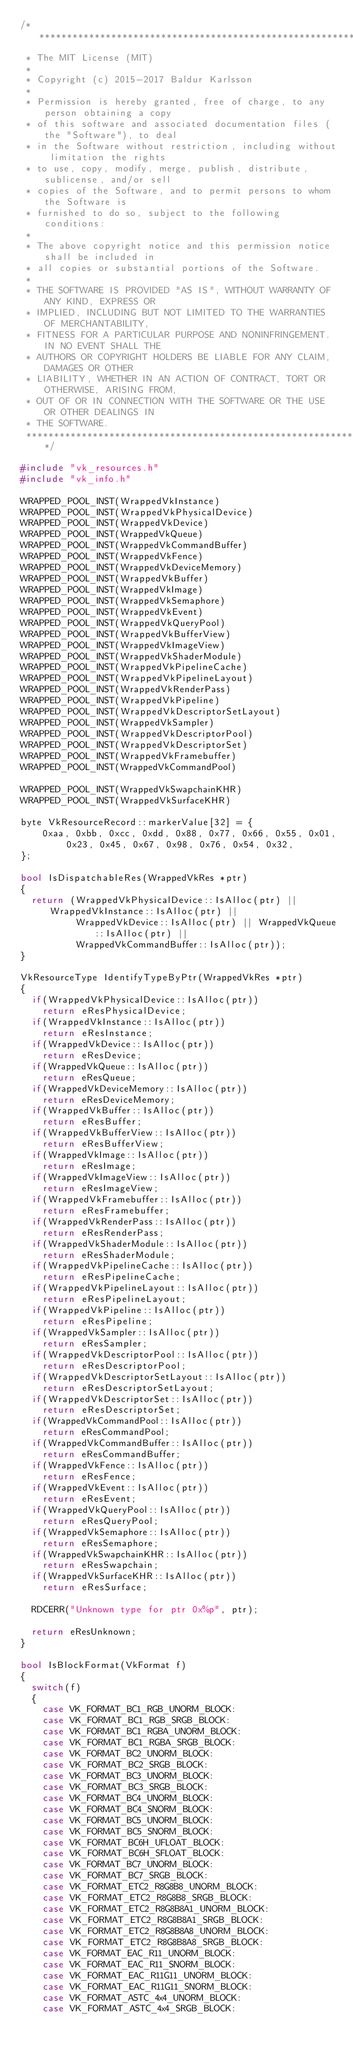Convert code to text. <code><loc_0><loc_0><loc_500><loc_500><_C++_>/******************************************************************************
 * The MIT License (MIT)
 *
 * Copyright (c) 2015-2017 Baldur Karlsson
 *
 * Permission is hereby granted, free of charge, to any person obtaining a copy
 * of this software and associated documentation files (the "Software"), to deal
 * in the Software without restriction, including without limitation the rights
 * to use, copy, modify, merge, publish, distribute, sublicense, and/or sell
 * copies of the Software, and to permit persons to whom the Software is
 * furnished to do so, subject to the following conditions:
 *
 * The above copyright notice and this permission notice shall be included in
 * all copies or substantial portions of the Software.
 *
 * THE SOFTWARE IS PROVIDED "AS IS", WITHOUT WARRANTY OF ANY KIND, EXPRESS OR
 * IMPLIED, INCLUDING BUT NOT LIMITED TO THE WARRANTIES OF MERCHANTABILITY,
 * FITNESS FOR A PARTICULAR PURPOSE AND NONINFRINGEMENT. IN NO EVENT SHALL THE
 * AUTHORS OR COPYRIGHT HOLDERS BE LIABLE FOR ANY CLAIM, DAMAGES OR OTHER
 * LIABILITY, WHETHER IN AN ACTION OF CONTRACT, TORT OR OTHERWISE, ARISING FROM,
 * OUT OF OR IN CONNECTION WITH THE SOFTWARE OR THE USE OR OTHER DEALINGS IN
 * THE SOFTWARE.
 ******************************************************************************/

#include "vk_resources.h"
#include "vk_info.h"

WRAPPED_POOL_INST(WrappedVkInstance)
WRAPPED_POOL_INST(WrappedVkPhysicalDevice)
WRAPPED_POOL_INST(WrappedVkDevice)
WRAPPED_POOL_INST(WrappedVkQueue)
WRAPPED_POOL_INST(WrappedVkCommandBuffer)
WRAPPED_POOL_INST(WrappedVkFence)
WRAPPED_POOL_INST(WrappedVkDeviceMemory)
WRAPPED_POOL_INST(WrappedVkBuffer)
WRAPPED_POOL_INST(WrappedVkImage)
WRAPPED_POOL_INST(WrappedVkSemaphore)
WRAPPED_POOL_INST(WrappedVkEvent)
WRAPPED_POOL_INST(WrappedVkQueryPool)
WRAPPED_POOL_INST(WrappedVkBufferView)
WRAPPED_POOL_INST(WrappedVkImageView)
WRAPPED_POOL_INST(WrappedVkShaderModule)
WRAPPED_POOL_INST(WrappedVkPipelineCache)
WRAPPED_POOL_INST(WrappedVkPipelineLayout)
WRAPPED_POOL_INST(WrappedVkRenderPass)
WRAPPED_POOL_INST(WrappedVkPipeline)
WRAPPED_POOL_INST(WrappedVkDescriptorSetLayout)
WRAPPED_POOL_INST(WrappedVkSampler)
WRAPPED_POOL_INST(WrappedVkDescriptorPool)
WRAPPED_POOL_INST(WrappedVkDescriptorSet)
WRAPPED_POOL_INST(WrappedVkFramebuffer)
WRAPPED_POOL_INST(WrappedVkCommandPool)

WRAPPED_POOL_INST(WrappedVkSwapchainKHR)
WRAPPED_POOL_INST(WrappedVkSurfaceKHR)

byte VkResourceRecord::markerValue[32] = {
    0xaa, 0xbb, 0xcc, 0xdd, 0x88, 0x77, 0x66, 0x55, 0x01, 0x23, 0x45, 0x67, 0x98, 0x76, 0x54, 0x32,
};

bool IsDispatchableRes(WrappedVkRes *ptr)
{
  return (WrappedVkPhysicalDevice::IsAlloc(ptr) || WrappedVkInstance::IsAlloc(ptr) ||
          WrappedVkDevice::IsAlloc(ptr) || WrappedVkQueue::IsAlloc(ptr) ||
          WrappedVkCommandBuffer::IsAlloc(ptr));
}

VkResourceType IdentifyTypeByPtr(WrappedVkRes *ptr)
{
  if(WrappedVkPhysicalDevice::IsAlloc(ptr))
    return eResPhysicalDevice;
  if(WrappedVkInstance::IsAlloc(ptr))
    return eResInstance;
  if(WrappedVkDevice::IsAlloc(ptr))
    return eResDevice;
  if(WrappedVkQueue::IsAlloc(ptr))
    return eResQueue;
  if(WrappedVkDeviceMemory::IsAlloc(ptr))
    return eResDeviceMemory;
  if(WrappedVkBuffer::IsAlloc(ptr))
    return eResBuffer;
  if(WrappedVkBufferView::IsAlloc(ptr))
    return eResBufferView;
  if(WrappedVkImage::IsAlloc(ptr))
    return eResImage;
  if(WrappedVkImageView::IsAlloc(ptr))
    return eResImageView;
  if(WrappedVkFramebuffer::IsAlloc(ptr))
    return eResFramebuffer;
  if(WrappedVkRenderPass::IsAlloc(ptr))
    return eResRenderPass;
  if(WrappedVkShaderModule::IsAlloc(ptr))
    return eResShaderModule;
  if(WrappedVkPipelineCache::IsAlloc(ptr))
    return eResPipelineCache;
  if(WrappedVkPipelineLayout::IsAlloc(ptr))
    return eResPipelineLayout;
  if(WrappedVkPipeline::IsAlloc(ptr))
    return eResPipeline;
  if(WrappedVkSampler::IsAlloc(ptr))
    return eResSampler;
  if(WrappedVkDescriptorPool::IsAlloc(ptr))
    return eResDescriptorPool;
  if(WrappedVkDescriptorSetLayout::IsAlloc(ptr))
    return eResDescriptorSetLayout;
  if(WrappedVkDescriptorSet::IsAlloc(ptr))
    return eResDescriptorSet;
  if(WrappedVkCommandPool::IsAlloc(ptr))
    return eResCommandPool;
  if(WrappedVkCommandBuffer::IsAlloc(ptr))
    return eResCommandBuffer;
  if(WrappedVkFence::IsAlloc(ptr))
    return eResFence;
  if(WrappedVkEvent::IsAlloc(ptr))
    return eResEvent;
  if(WrappedVkQueryPool::IsAlloc(ptr))
    return eResQueryPool;
  if(WrappedVkSemaphore::IsAlloc(ptr))
    return eResSemaphore;
  if(WrappedVkSwapchainKHR::IsAlloc(ptr))
    return eResSwapchain;
  if(WrappedVkSurfaceKHR::IsAlloc(ptr))
    return eResSurface;

  RDCERR("Unknown type for ptr 0x%p", ptr);

  return eResUnknown;
}

bool IsBlockFormat(VkFormat f)
{
  switch(f)
  {
    case VK_FORMAT_BC1_RGB_UNORM_BLOCK:
    case VK_FORMAT_BC1_RGB_SRGB_BLOCK:
    case VK_FORMAT_BC1_RGBA_UNORM_BLOCK:
    case VK_FORMAT_BC1_RGBA_SRGB_BLOCK:
    case VK_FORMAT_BC2_UNORM_BLOCK:
    case VK_FORMAT_BC2_SRGB_BLOCK:
    case VK_FORMAT_BC3_UNORM_BLOCK:
    case VK_FORMAT_BC3_SRGB_BLOCK:
    case VK_FORMAT_BC4_UNORM_BLOCK:
    case VK_FORMAT_BC4_SNORM_BLOCK:
    case VK_FORMAT_BC5_UNORM_BLOCK:
    case VK_FORMAT_BC5_SNORM_BLOCK:
    case VK_FORMAT_BC6H_UFLOAT_BLOCK:
    case VK_FORMAT_BC6H_SFLOAT_BLOCK:
    case VK_FORMAT_BC7_UNORM_BLOCK:
    case VK_FORMAT_BC7_SRGB_BLOCK:
    case VK_FORMAT_ETC2_R8G8B8_UNORM_BLOCK:
    case VK_FORMAT_ETC2_R8G8B8_SRGB_BLOCK:
    case VK_FORMAT_ETC2_R8G8B8A1_UNORM_BLOCK:
    case VK_FORMAT_ETC2_R8G8B8A1_SRGB_BLOCK:
    case VK_FORMAT_ETC2_R8G8B8A8_UNORM_BLOCK:
    case VK_FORMAT_ETC2_R8G8B8A8_SRGB_BLOCK:
    case VK_FORMAT_EAC_R11_UNORM_BLOCK:
    case VK_FORMAT_EAC_R11_SNORM_BLOCK:
    case VK_FORMAT_EAC_R11G11_UNORM_BLOCK:
    case VK_FORMAT_EAC_R11G11_SNORM_BLOCK:
    case VK_FORMAT_ASTC_4x4_UNORM_BLOCK:
    case VK_FORMAT_ASTC_4x4_SRGB_BLOCK:</code> 